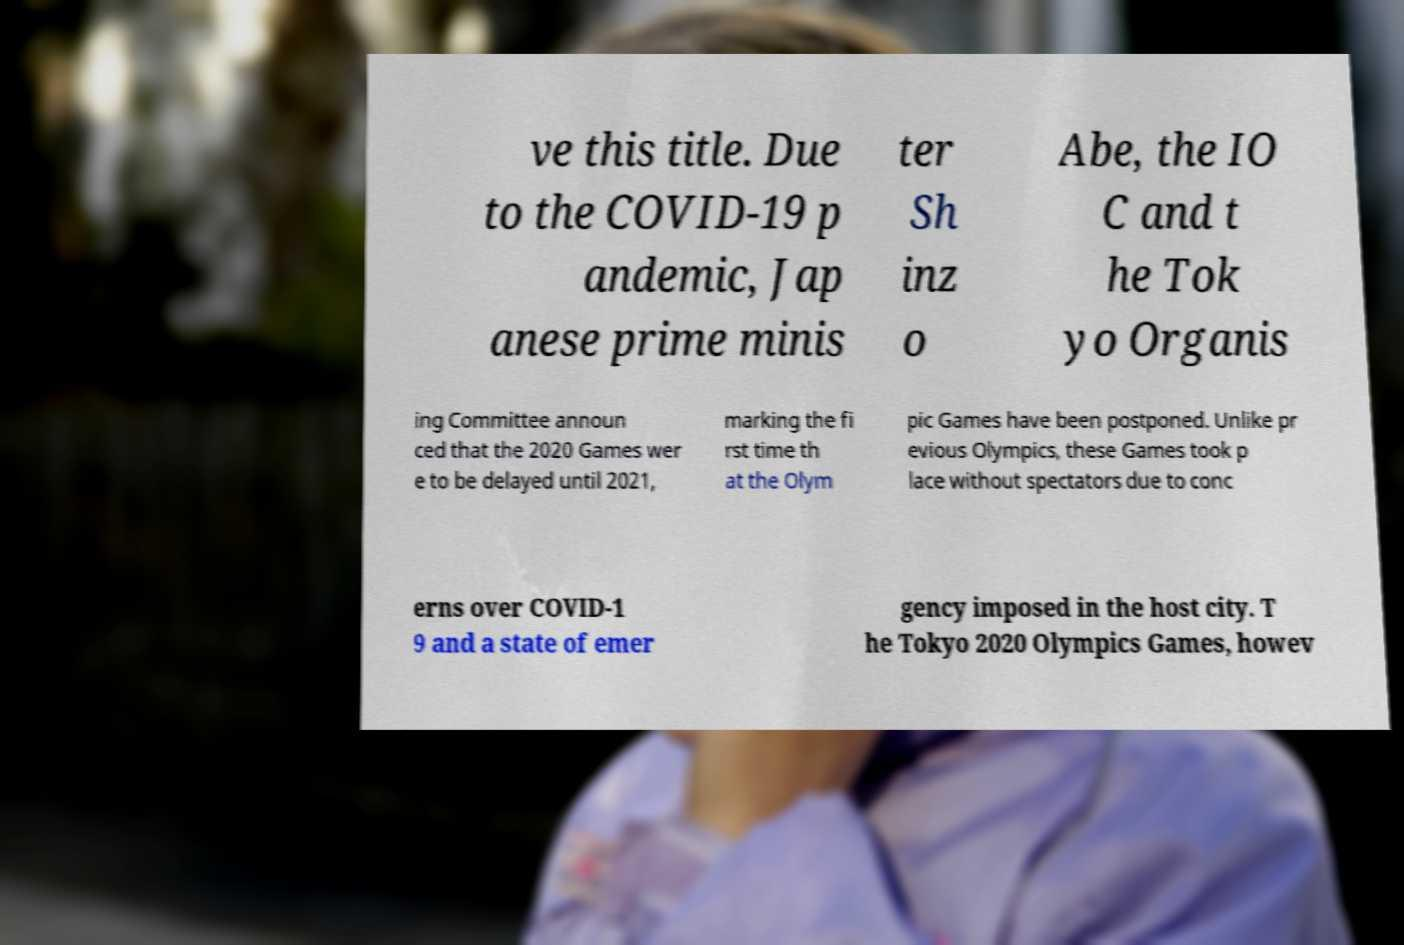Could you assist in decoding the text presented in this image and type it out clearly? ve this title. Due to the COVID-19 p andemic, Jap anese prime minis ter Sh inz o Abe, the IO C and t he Tok yo Organis ing Committee announ ced that the 2020 Games wer e to be delayed until 2021, marking the fi rst time th at the Olym pic Games have been postponed. Unlike pr evious Olympics, these Games took p lace without spectators due to conc erns over COVID-1 9 and a state of emer gency imposed in the host city. T he Tokyo 2020 Olympics Games, howev 